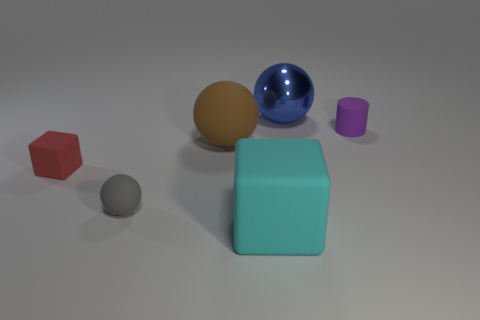There is a matte block on the right side of the red matte thing that is left of the large cyan block; what number of large rubber things are behind it?
Ensure brevity in your answer.  1. What is the color of the large object that is on the left side of the cyan cube?
Offer a very short reply. Brown. What is the thing that is behind the large matte ball and to the left of the rubber cylinder made of?
Provide a succinct answer. Metal. There is a large rubber thing that is to the right of the brown thing; what number of tiny rubber objects are on the right side of it?
Offer a very short reply. 1. There is a tiny red object; what shape is it?
Provide a short and direct response. Cube. There is a tiny red thing that is made of the same material as the small purple object; what is its shape?
Offer a very short reply. Cube. There is a matte thing behind the big brown sphere; is its shape the same as the cyan rubber thing?
Provide a short and direct response. No. What is the shape of the tiny rubber object on the right side of the gray rubber ball?
Offer a very short reply. Cylinder. How many rubber blocks are the same size as the purple matte object?
Offer a terse response. 1. What is the color of the tiny matte cylinder?
Offer a terse response. Purple. 